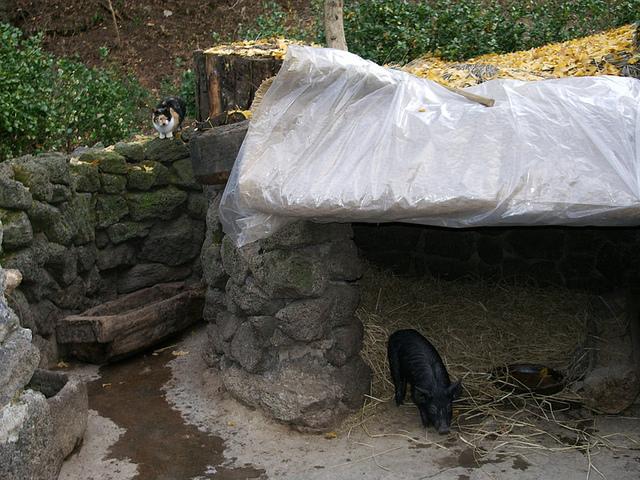What is on the ground in the cave?
Be succinct. Pig. What is the animal?
Answer briefly. Pig. Is there a cat in the picture?
Keep it brief. Yes. 